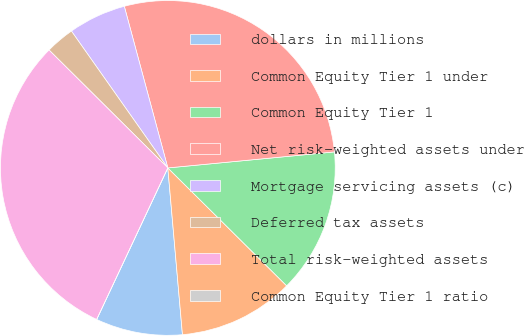Convert chart to OTSL. <chart><loc_0><loc_0><loc_500><loc_500><pie_chart><fcel>dollars in millions<fcel>Common Equity Tier 1 under<fcel>Common Equity Tier 1<fcel>Net risk-weighted assets under<fcel>Mortgage servicing assets (c)<fcel>Deferred tax assets<fcel>Total risk-weighted assets<fcel>Common Equity Tier 1 ratio<nl><fcel>8.38%<fcel>11.17%<fcel>13.96%<fcel>27.66%<fcel>5.58%<fcel>2.79%<fcel>30.45%<fcel>0.0%<nl></chart> 